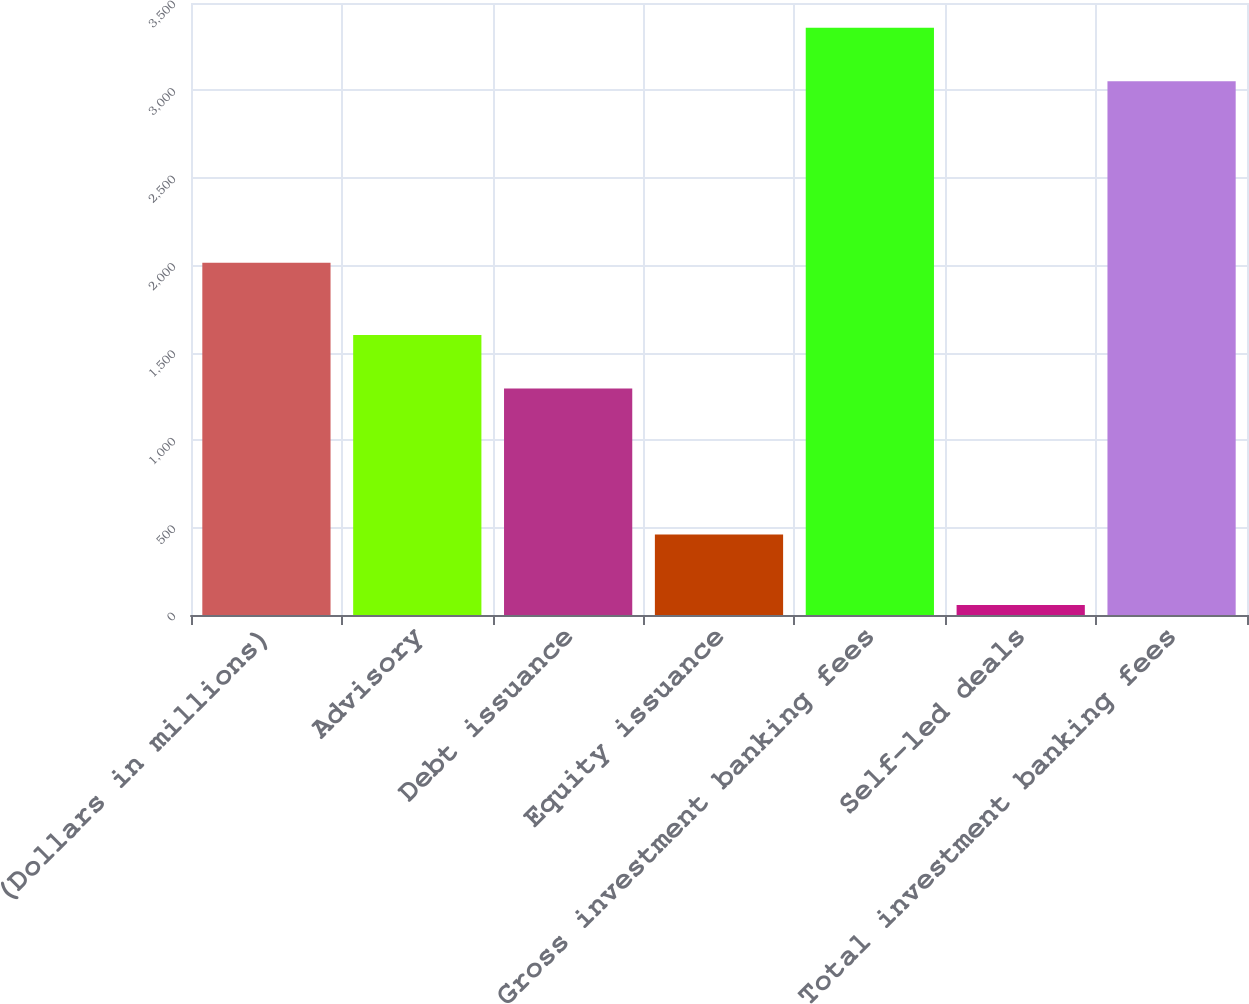Convert chart to OTSL. <chart><loc_0><loc_0><loc_500><loc_500><bar_chart><fcel>(Dollars in millions)<fcel>Advisory<fcel>Debt issuance<fcel>Equity issuance<fcel>Gross investment banking fees<fcel>Self-led deals<fcel>Total investment banking fees<nl><fcel>2015<fcel>1601.3<fcel>1296<fcel>460<fcel>3358.3<fcel>57<fcel>3053<nl></chart> 